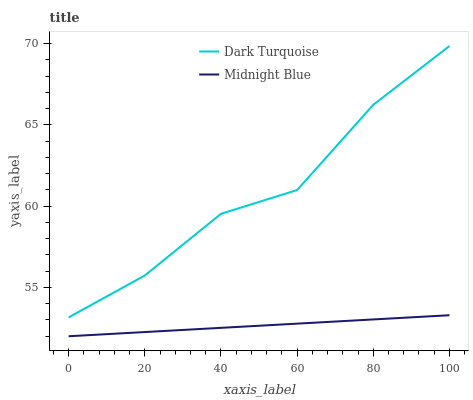Does Midnight Blue have the minimum area under the curve?
Answer yes or no. Yes. Does Dark Turquoise have the maximum area under the curve?
Answer yes or no. Yes. Does Midnight Blue have the maximum area under the curve?
Answer yes or no. No. Is Midnight Blue the smoothest?
Answer yes or no. Yes. Is Dark Turquoise the roughest?
Answer yes or no. Yes. Is Midnight Blue the roughest?
Answer yes or no. No. Does Midnight Blue have the lowest value?
Answer yes or no. Yes. Does Dark Turquoise have the highest value?
Answer yes or no. Yes. Does Midnight Blue have the highest value?
Answer yes or no. No. Is Midnight Blue less than Dark Turquoise?
Answer yes or no. Yes. Is Dark Turquoise greater than Midnight Blue?
Answer yes or no. Yes. Does Midnight Blue intersect Dark Turquoise?
Answer yes or no. No. 